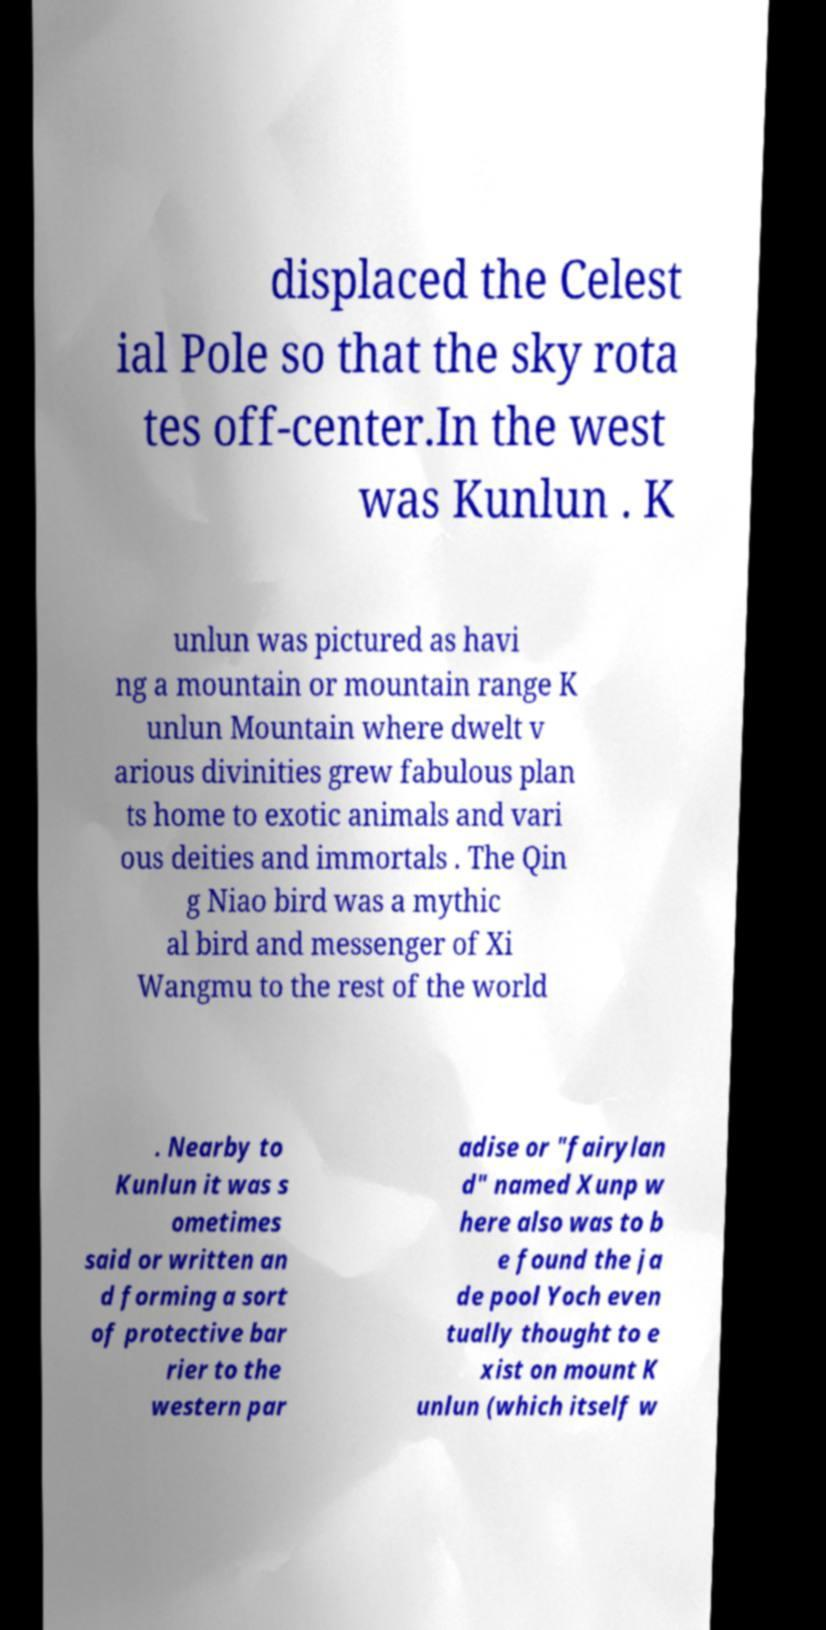Please identify and transcribe the text found in this image. displaced the Celest ial Pole so that the sky rota tes off-center.In the west was Kunlun . K unlun was pictured as havi ng a mountain or mountain range K unlun Mountain where dwelt v arious divinities grew fabulous plan ts home to exotic animals and vari ous deities and immortals . The Qin g Niao bird was a mythic al bird and messenger of Xi Wangmu to the rest of the world . Nearby to Kunlun it was s ometimes said or written an d forming a sort of protective bar rier to the western par adise or "fairylan d" named Xunp w here also was to b e found the ja de pool Yoch even tually thought to e xist on mount K unlun (which itself w 